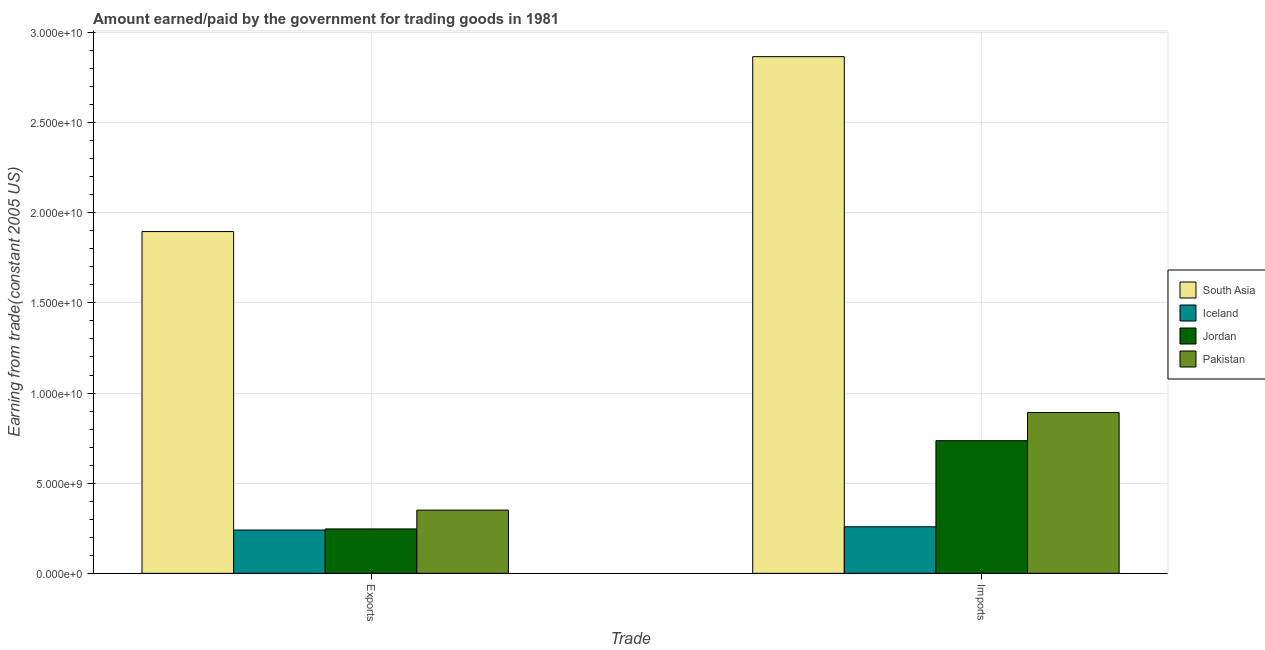How many groups of bars are there?
Provide a short and direct response. 2. How many bars are there on the 1st tick from the right?
Keep it short and to the point. 4. What is the label of the 2nd group of bars from the left?
Keep it short and to the point. Imports. What is the amount paid for imports in Iceland?
Your answer should be very brief. 2.58e+09. Across all countries, what is the maximum amount earned from exports?
Offer a terse response. 1.90e+1. Across all countries, what is the minimum amount paid for imports?
Ensure brevity in your answer.  2.58e+09. In which country was the amount earned from exports minimum?
Give a very brief answer. Iceland. What is the total amount paid for imports in the graph?
Provide a short and direct response. 4.75e+1. What is the difference between the amount earned from exports in South Asia and that in Jordan?
Ensure brevity in your answer.  1.65e+1. What is the difference between the amount paid for imports in Iceland and the amount earned from exports in Pakistan?
Offer a terse response. -9.24e+08. What is the average amount earned from exports per country?
Make the answer very short. 6.83e+09. What is the difference between the amount earned from exports and amount paid for imports in Pakistan?
Provide a succinct answer. -5.41e+09. In how many countries, is the amount paid for imports greater than 25000000000 US$?
Your answer should be very brief. 1. What is the ratio of the amount paid for imports in Pakistan to that in Iceland?
Give a very brief answer. 3.45. Is the amount paid for imports in South Asia less than that in Iceland?
Make the answer very short. No. In how many countries, is the amount paid for imports greater than the average amount paid for imports taken over all countries?
Offer a terse response. 1. How many bars are there?
Offer a terse response. 8. What is the difference between two consecutive major ticks on the Y-axis?
Give a very brief answer. 5.00e+09. Are the values on the major ticks of Y-axis written in scientific E-notation?
Provide a succinct answer. Yes. Does the graph contain any zero values?
Keep it short and to the point. No. Does the graph contain grids?
Provide a short and direct response. Yes. Where does the legend appear in the graph?
Provide a short and direct response. Center right. How many legend labels are there?
Make the answer very short. 4. How are the legend labels stacked?
Offer a very short reply. Vertical. What is the title of the graph?
Make the answer very short. Amount earned/paid by the government for trading goods in 1981. What is the label or title of the X-axis?
Provide a succinct answer. Trade. What is the label or title of the Y-axis?
Ensure brevity in your answer.  Earning from trade(constant 2005 US). What is the Earning from trade(constant 2005 US) in South Asia in Exports?
Offer a very short reply. 1.90e+1. What is the Earning from trade(constant 2005 US) of Iceland in Exports?
Offer a very short reply. 2.40e+09. What is the Earning from trade(constant 2005 US) of Jordan in Exports?
Provide a short and direct response. 2.46e+09. What is the Earning from trade(constant 2005 US) in Pakistan in Exports?
Offer a very short reply. 3.51e+09. What is the Earning from trade(constant 2005 US) of South Asia in Imports?
Ensure brevity in your answer.  2.87e+1. What is the Earning from trade(constant 2005 US) in Iceland in Imports?
Offer a very short reply. 2.58e+09. What is the Earning from trade(constant 2005 US) of Jordan in Imports?
Your answer should be very brief. 7.36e+09. What is the Earning from trade(constant 2005 US) of Pakistan in Imports?
Your answer should be very brief. 8.92e+09. Across all Trade, what is the maximum Earning from trade(constant 2005 US) of South Asia?
Make the answer very short. 2.87e+1. Across all Trade, what is the maximum Earning from trade(constant 2005 US) of Iceland?
Provide a short and direct response. 2.58e+09. Across all Trade, what is the maximum Earning from trade(constant 2005 US) in Jordan?
Your response must be concise. 7.36e+09. Across all Trade, what is the maximum Earning from trade(constant 2005 US) in Pakistan?
Give a very brief answer. 8.92e+09. Across all Trade, what is the minimum Earning from trade(constant 2005 US) in South Asia?
Provide a succinct answer. 1.90e+1. Across all Trade, what is the minimum Earning from trade(constant 2005 US) of Iceland?
Offer a very short reply. 2.40e+09. Across all Trade, what is the minimum Earning from trade(constant 2005 US) in Jordan?
Provide a succinct answer. 2.46e+09. Across all Trade, what is the minimum Earning from trade(constant 2005 US) in Pakistan?
Keep it short and to the point. 3.51e+09. What is the total Earning from trade(constant 2005 US) in South Asia in the graph?
Give a very brief answer. 4.76e+1. What is the total Earning from trade(constant 2005 US) in Iceland in the graph?
Your response must be concise. 4.98e+09. What is the total Earning from trade(constant 2005 US) of Jordan in the graph?
Provide a short and direct response. 9.82e+09. What is the total Earning from trade(constant 2005 US) of Pakistan in the graph?
Your response must be concise. 1.24e+1. What is the difference between the Earning from trade(constant 2005 US) of South Asia in Exports and that in Imports?
Offer a terse response. -9.70e+09. What is the difference between the Earning from trade(constant 2005 US) of Iceland in Exports and that in Imports?
Provide a short and direct response. -1.80e+08. What is the difference between the Earning from trade(constant 2005 US) of Jordan in Exports and that in Imports?
Your answer should be compact. -4.89e+09. What is the difference between the Earning from trade(constant 2005 US) of Pakistan in Exports and that in Imports?
Offer a very short reply. -5.41e+09. What is the difference between the Earning from trade(constant 2005 US) in South Asia in Exports and the Earning from trade(constant 2005 US) in Iceland in Imports?
Provide a succinct answer. 1.64e+1. What is the difference between the Earning from trade(constant 2005 US) of South Asia in Exports and the Earning from trade(constant 2005 US) of Jordan in Imports?
Ensure brevity in your answer.  1.16e+1. What is the difference between the Earning from trade(constant 2005 US) in South Asia in Exports and the Earning from trade(constant 2005 US) in Pakistan in Imports?
Keep it short and to the point. 1.00e+1. What is the difference between the Earning from trade(constant 2005 US) in Iceland in Exports and the Earning from trade(constant 2005 US) in Jordan in Imports?
Make the answer very short. -4.95e+09. What is the difference between the Earning from trade(constant 2005 US) in Iceland in Exports and the Earning from trade(constant 2005 US) in Pakistan in Imports?
Make the answer very short. -6.52e+09. What is the difference between the Earning from trade(constant 2005 US) of Jordan in Exports and the Earning from trade(constant 2005 US) of Pakistan in Imports?
Make the answer very short. -6.46e+09. What is the average Earning from trade(constant 2005 US) in South Asia per Trade?
Keep it short and to the point. 2.38e+1. What is the average Earning from trade(constant 2005 US) of Iceland per Trade?
Your answer should be compact. 2.49e+09. What is the average Earning from trade(constant 2005 US) in Jordan per Trade?
Offer a terse response. 4.91e+09. What is the average Earning from trade(constant 2005 US) in Pakistan per Trade?
Offer a very short reply. 6.21e+09. What is the difference between the Earning from trade(constant 2005 US) of South Asia and Earning from trade(constant 2005 US) of Iceland in Exports?
Provide a succinct answer. 1.66e+1. What is the difference between the Earning from trade(constant 2005 US) in South Asia and Earning from trade(constant 2005 US) in Jordan in Exports?
Offer a very short reply. 1.65e+1. What is the difference between the Earning from trade(constant 2005 US) of South Asia and Earning from trade(constant 2005 US) of Pakistan in Exports?
Your answer should be compact. 1.55e+1. What is the difference between the Earning from trade(constant 2005 US) in Iceland and Earning from trade(constant 2005 US) in Jordan in Exports?
Provide a short and direct response. -6.01e+07. What is the difference between the Earning from trade(constant 2005 US) in Iceland and Earning from trade(constant 2005 US) in Pakistan in Exports?
Ensure brevity in your answer.  -1.10e+09. What is the difference between the Earning from trade(constant 2005 US) in Jordan and Earning from trade(constant 2005 US) in Pakistan in Exports?
Keep it short and to the point. -1.04e+09. What is the difference between the Earning from trade(constant 2005 US) of South Asia and Earning from trade(constant 2005 US) of Iceland in Imports?
Give a very brief answer. 2.61e+1. What is the difference between the Earning from trade(constant 2005 US) in South Asia and Earning from trade(constant 2005 US) in Jordan in Imports?
Provide a short and direct response. 2.13e+1. What is the difference between the Earning from trade(constant 2005 US) of South Asia and Earning from trade(constant 2005 US) of Pakistan in Imports?
Make the answer very short. 1.97e+1. What is the difference between the Earning from trade(constant 2005 US) in Iceland and Earning from trade(constant 2005 US) in Jordan in Imports?
Provide a succinct answer. -4.78e+09. What is the difference between the Earning from trade(constant 2005 US) of Iceland and Earning from trade(constant 2005 US) of Pakistan in Imports?
Give a very brief answer. -6.34e+09. What is the difference between the Earning from trade(constant 2005 US) of Jordan and Earning from trade(constant 2005 US) of Pakistan in Imports?
Give a very brief answer. -1.56e+09. What is the ratio of the Earning from trade(constant 2005 US) of South Asia in Exports to that in Imports?
Offer a very short reply. 0.66. What is the ratio of the Earning from trade(constant 2005 US) of Iceland in Exports to that in Imports?
Your answer should be compact. 0.93. What is the ratio of the Earning from trade(constant 2005 US) in Jordan in Exports to that in Imports?
Provide a succinct answer. 0.33. What is the ratio of the Earning from trade(constant 2005 US) in Pakistan in Exports to that in Imports?
Make the answer very short. 0.39. What is the difference between the highest and the second highest Earning from trade(constant 2005 US) of South Asia?
Provide a succinct answer. 9.70e+09. What is the difference between the highest and the second highest Earning from trade(constant 2005 US) of Iceland?
Make the answer very short. 1.80e+08. What is the difference between the highest and the second highest Earning from trade(constant 2005 US) in Jordan?
Provide a short and direct response. 4.89e+09. What is the difference between the highest and the second highest Earning from trade(constant 2005 US) in Pakistan?
Offer a very short reply. 5.41e+09. What is the difference between the highest and the lowest Earning from trade(constant 2005 US) of South Asia?
Make the answer very short. 9.70e+09. What is the difference between the highest and the lowest Earning from trade(constant 2005 US) of Iceland?
Keep it short and to the point. 1.80e+08. What is the difference between the highest and the lowest Earning from trade(constant 2005 US) of Jordan?
Ensure brevity in your answer.  4.89e+09. What is the difference between the highest and the lowest Earning from trade(constant 2005 US) in Pakistan?
Offer a terse response. 5.41e+09. 